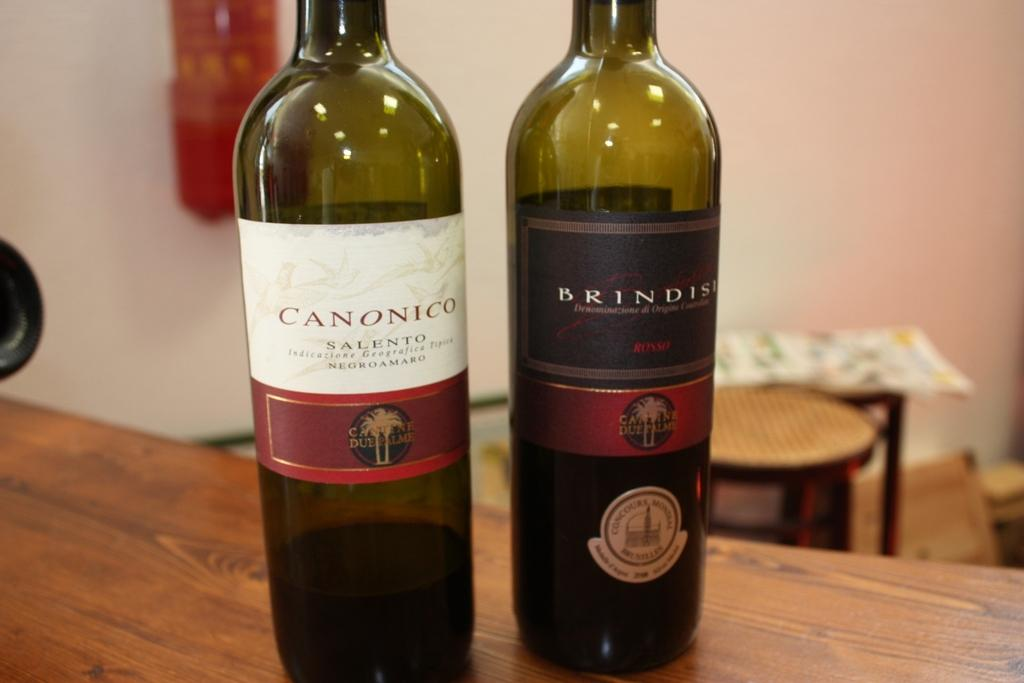Provide a one-sentence caption for the provided image. A green Canonico wine bottle sits next to another bottle. 